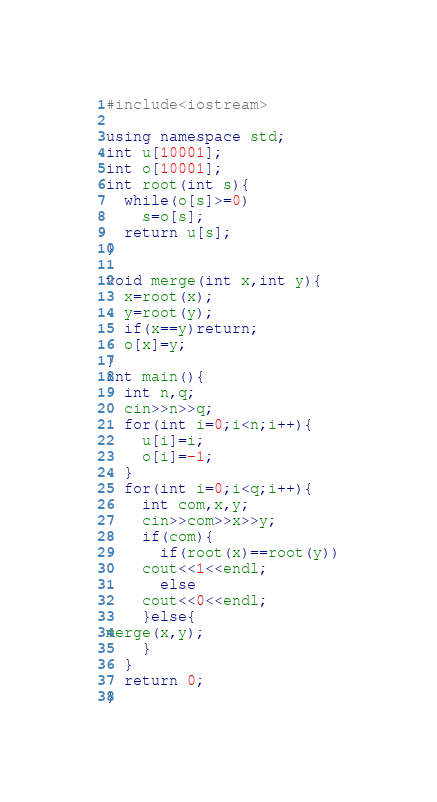<code> <loc_0><loc_0><loc_500><loc_500><_C++_>#include<iostream>

using namespace std;
int u[10001];
int o[10001];
int root(int s){
  while(o[s]>=0)
    s=o[s];
  return u[s];
}

void merge(int x,int y){
  x=root(x);
  y=root(y);
  if(x==y)return;
  o[x]=y;
}
int main(){
  int n,q;
  cin>>n>>q;
  for(int i=0;i<n;i++){
    u[i]=i;
    o[i]=-1;
  }
  for(int i=0;i<q;i++){
    int com,x,y;
    cin>>com>>x>>y;
    if(com){
      if(root(x)==root(y))
	cout<<1<<endl;
      else
	cout<<0<<endl;
    }else{
merge(x,y);
    }
  }
  return 0;
}</code> 